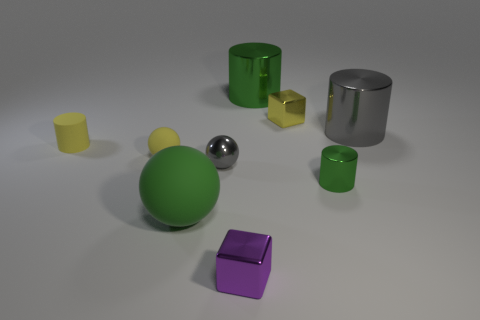Subtract all small yellow rubber cylinders. How many cylinders are left? 3 Subtract all gray cubes. How many green cylinders are left? 2 Subtract 1 spheres. How many spheres are left? 2 Subtract all yellow spheres. How many spheres are left? 2 Subtract 0 green cubes. How many objects are left? 9 Subtract all cylinders. How many objects are left? 5 Subtract all cyan cubes. Subtract all gray cylinders. How many cubes are left? 2 Subtract all yellow shiny blocks. Subtract all yellow shiny blocks. How many objects are left? 7 Add 1 green spheres. How many green spheres are left? 2 Add 9 large balls. How many large balls exist? 10 